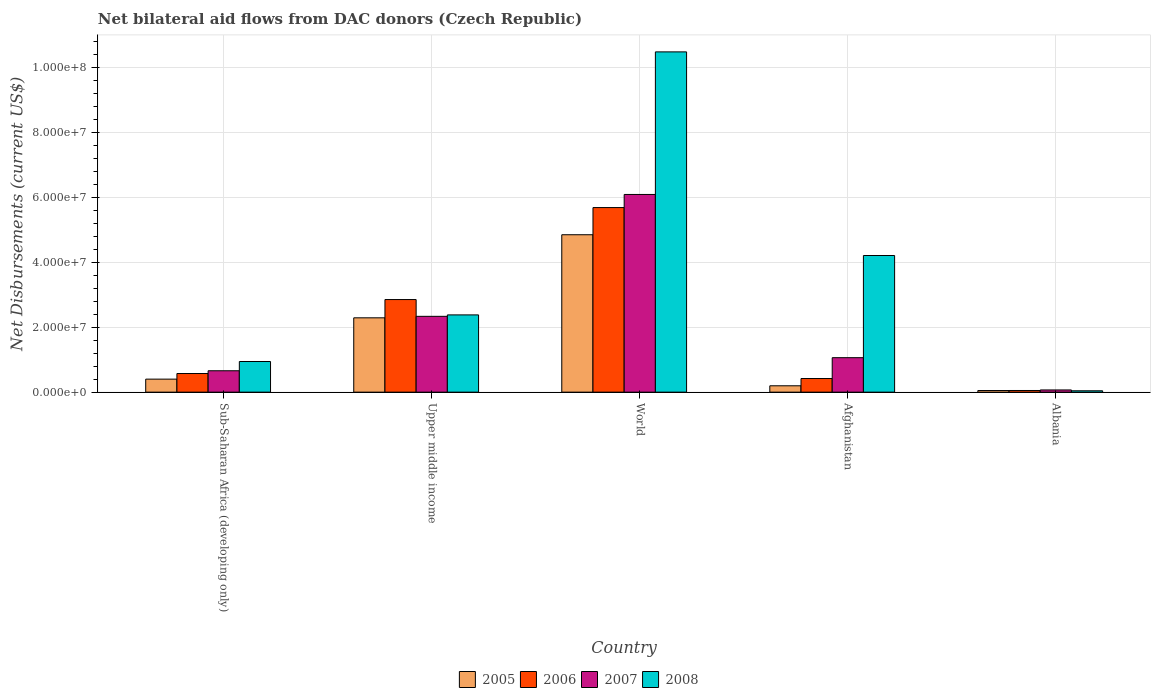How many groups of bars are there?
Your answer should be compact. 5. Are the number of bars per tick equal to the number of legend labels?
Keep it short and to the point. Yes. How many bars are there on the 5th tick from the left?
Give a very brief answer. 4. How many bars are there on the 3rd tick from the right?
Make the answer very short. 4. What is the label of the 3rd group of bars from the left?
Your answer should be very brief. World. What is the net bilateral aid flows in 2008 in World?
Offer a very short reply. 1.05e+08. Across all countries, what is the maximum net bilateral aid flows in 2006?
Give a very brief answer. 5.69e+07. In which country was the net bilateral aid flows in 2005 minimum?
Your response must be concise. Albania. What is the total net bilateral aid flows in 2007 in the graph?
Offer a very short reply. 1.02e+08. What is the difference between the net bilateral aid flows in 2006 in Upper middle income and that in World?
Offer a very short reply. -2.83e+07. What is the difference between the net bilateral aid flows in 2005 in Afghanistan and the net bilateral aid flows in 2007 in World?
Offer a terse response. -5.90e+07. What is the average net bilateral aid flows in 2005 per country?
Your answer should be very brief. 1.56e+07. What is the difference between the net bilateral aid flows of/in 2008 and net bilateral aid flows of/in 2007 in Upper middle income?
Provide a succinct answer. 4.40e+05. In how many countries, is the net bilateral aid flows in 2006 greater than 24000000 US$?
Ensure brevity in your answer.  2. What is the ratio of the net bilateral aid flows in 2005 in Sub-Saharan Africa (developing only) to that in Upper middle income?
Offer a very short reply. 0.18. Is the net bilateral aid flows in 2006 in Albania less than that in Upper middle income?
Provide a succinct answer. Yes. Is the difference between the net bilateral aid flows in 2008 in Sub-Saharan Africa (developing only) and Upper middle income greater than the difference between the net bilateral aid flows in 2007 in Sub-Saharan Africa (developing only) and Upper middle income?
Ensure brevity in your answer.  Yes. What is the difference between the highest and the second highest net bilateral aid flows in 2008?
Ensure brevity in your answer.  6.27e+07. What is the difference between the highest and the lowest net bilateral aid flows in 2008?
Provide a succinct answer. 1.04e+08. Is the sum of the net bilateral aid flows in 2007 in Sub-Saharan Africa (developing only) and World greater than the maximum net bilateral aid flows in 2006 across all countries?
Offer a terse response. Yes. What does the 3rd bar from the left in Upper middle income represents?
Provide a short and direct response. 2007. What does the 1st bar from the right in Upper middle income represents?
Offer a terse response. 2008. Is it the case that in every country, the sum of the net bilateral aid flows in 2007 and net bilateral aid flows in 2008 is greater than the net bilateral aid flows in 2005?
Provide a succinct answer. Yes. How many bars are there?
Give a very brief answer. 20. Are all the bars in the graph horizontal?
Your response must be concise. No. Are the values on the major ticks of Y-axis written in scientific E-notation?
Keep it short and to the point. Yes. Does the graph contain any zero values?
Offer a very short reply. No. Does the graph contain grids?
Ensure brevity in your answer.  Yes. How many legend labels are there?
Give a very brief answer. 4. What is the title of the graph?
Ensure brevity in your answer.  Net bilateral aid flows from DAC donors (Czech Republic). What is the label or title of the X-axis?
Offer a very short reply. Country. What is the label or title of the Y-axis?
Your answer should be very brief. Net Disbursements (current US$). What is the Net Disbursements (current US$) in 2005 in Sub-Saharan Africa (developing only)?
Your answer should be very brief. 4.01e+06. What is the Net Disbursements (current US$) in 2006 in Sub-Saharan Africa (developing only)?
Give a very brief answer. 5.74e+06. What is the Net Disbursements (current US$) in 2007 in Sub-Saharan Africa (developing only)?
Offer a terse response. 6.59e+06. What is the Net Disbursements (current US$) in 2008 in Sub-Saharan Africa (developing only)?
Provide a short and direct response. 9.44e+06. What is the Net Disbursements (current US$) in 2005 in Upper middle income?
Offer a very short reply. 2.29e+07. What is the Net Disbursements (current US$) in 2006 in Upper middle income?
Offer a terse response. 2.85e+07. What is the Net Disbursements (current US$) in 2007 in Upper middle income?
Offer a terse response. 2.34e+07. What is the Net Disbursements (current US$) of 2008 in Upper middle income?
Offer a terse response. 2.38e+07. What is the Net Disbursements (current US$) of 2005 in World?
Offer a terse response. 4.85e+07. What is the Net Disbursements (current US$) in 2006 in World?
Your answer should be very brief. 5.69e+07. What is the Net Disbursements (current US$) of 2007 in World?
Make the answer very short. 6.09e+07. What is the Net Disbursements (current US$) in 2008 in World?
Give a very brief answer. 1.05e+08. What is the Net Disbursements (current US$) in 2005 in Afghanistan?
Give a very brief answer. 1.96e+06. What is the Net Disbursements (current US$) of 2006 in Afghanistan?
Your answer should be compact. 4.20e+06. What is the Net Disbursements (current US$) in 2007 in Afghanistan?
Offer a terse response. 1.06e+07. What is the Net Disbursements (current US$) in 2008 in Afghanistan?
Provide a short and direct response. 4.21e+07. What is the Net Disbursements (current US$) in 2005 in Albania?
Your answer should be very brief. 5.00e+05. What is the Net Disbursements (current US$) in 2006 in Albania?
Provide a short and direct response. 5.10e+05. What is the Net Disbursements (current US$) of 2007 in Albania?
Offer a very short reply. 6.80e+05. Across all countries, what is the maximum Net Disbursements (current US$) of 2005?
Your answer should be compact. 4.85e+07. Across all countries, what is the maximum Net Disbursements (current US$) of 2006?
Provide a short and direct response. 5.69e+07. Across all countries, what is the maximum Net Disbursements (current US$) of 2007?
Keep it short and to the point. 6.09e+07. Across all countries, what is the maximum Net Disbursements (current US$) of 2008?
Make the answer very short. 1.05e+08. Across all countries, what is the minimum Net Disbursements (current US$) of 2006?
Provide a short and direct response. 5.10e+05. Across all countries, what is the minimum Net Disbursements (current US$) in 2007?
Keep it short and to the point. 6.80e+05. What is the total Net Disbursements (current US$) of 2005 in the graph?
Your response must be concise. 7.79e+07. What is the total Net Disbursements (current US$) in 2006 in the graph?
Keep it short and to the point. 9.58e+07. What is the total Net Disbursements (current US$) of 2007 in the graph?
Your response must be concise. 1.02e+08. What is the total Net Disbursements (current US$) of 2008 in the graph?
Keep it short and to the point. 1.81e+08. What is the difference between the Net Disbursements (current US$) of 2005 in Sub-Saharan Africa (developing only) and that in Upper middle income?
Offer a terse response. -1.89e+07. What is the difference between the Net Disbursements (current US$) of 2006 in Sub-Saharan Africa (developing only) and that in Upper middle income?
Your answer should be compact. -2.28e+07. What is the difference between the Net Disbursements (current US$) in 2007 in Sub-Saharan Africa (developing only) and that in Upper middle income?
Offer a very short reply. -1.68e+07. What is the difference between the Net Disbursements (current US$) of 2008 in Sub-Saharan Africa (developing only) and that in Upper middle income?
Ensure brevity in your answer.  -1.44e+07. What is the difference between the Net Disbursements (current US$) of 2005 in Sub-Saharan Africa (developing only) and that in World?
Offer a very short reply. -4.45e+07. What is the difference between the Net Disbursements (current US$) of 2006 in Sub-Saharan Africa (developing only) and that in World?
Ensure brevity in your answer.  -5.11e+07. What is the difference between the Net Disbursements (current US$) of 2007 in Sub-Saharan Africa (developing only) and that in World?
Offer a very short reply. -5.43e+07. What is the difference between the Net Disbursements (current US$) in 2008 in Sub-Saharan Africa (developing only) and that in World?
Your response must be concise. -9.54e+07. What is the difference between the Net Disbursements (current US$) of 2005 in Sub-Saharan Africa (developing only) and that in Afghanistan?
Your answer should be compact. 2.05e+06. What is the difference between the Net Disbursements (current US$) in 2006 in Sub-Saharan Africa (developing only) and that in Afghanistan?
Your answer should be very brief. 1.54e+06. What is the difference between the Net Disbursements (current US$) of 2007 in Sub-Saharan Africa (developing only) and that in Afghanistan?
Offer a very short reply. -4.03e+06. What is the difference between the Net Disbursements (current US$) of 2008 in Sub-Saharan Africa (developing only) and that in Afghanistan?
Give a very brief answer. -3.27e+07. What is the difference between the Net Disbursements (current US$) of 2005 in Sub-Saharan Africa (developing only) and that in Albania?
Ensure brevity in your answer.  3.51e+06. What is the difference between the Net Disbursements (current US$) in 2006 in Sub-Saharan Africa (developing only) and that in Albania?
Ensure brevity in your answer.  5.23e+06. What is the difference between the Net Disbursements (current US$) of 2007 in Sub-Saharan Africa (developing only) and that in Albania?
Make the answer very short. 5.91e+06. What is the difference between the Net Disbursements (current US$) of 2008 in Sub-Saharan Africa (developing only) and that in Albania?
Provide a succinct answer. 9.02e+06. What is the difference between the Net Disbursements (current US$) in 2005 in Upper middle income and that in World?
Provide a succinct answer. -2.56e+07. What is the difference between the Net Disbursements (current US$) in 2006 in Upper middle income and that in World?
Make the answer very short. -2.83e+07. What is the difference between the Net Disbursements (current US$) in 2007 in Upper middle income and that in World?
Your answer should be compact. -3.76e+07. What is the difference between the Net Disbursements (current US$) of 2008 in Upper middle income and that in World?
Make the answer very short. -8.10e+07. What is the difference between the Net Disbursements (current US$) of 2005 in Upper middle income and that in Afghanistan?
Provide a short and direct response. 2.09e+07. What is the difference between the Net Disbursements (current US$) in 2006 in Upper middle income and that in Afghanistan?
Provide a succinct answer. 2.43e+07. What is the difference between the Net Disbursements (current US$) of 2007 in Upper middle income and that in Afghanistan?
Offer a very short reply. 1.27e+07. What is the difference between the Net Disbursements (current US$) of 2008 in Upper middle income and that in Afghanistan?
Offer a very short reply. -1.83e+07. What is the difference between the Net Disbursements (current US$) in 2005 in Upper middle income and that in Albania?
Provide a succinct answer. 2.24e+07. What is the difference between the Net Disbursements (current US$) in 2006 in Upper middle income and that in Albania?
Give a very brief answer. 2.80e+07. What is the difference between the Net Disbursements (current US$) in 2007 in Upper middle income and that in Albania?
Your answer should be compact. 2.27e+07. What is the difference between the Net Disbursements (current US$) in 2008 in Upper middle income and that in Albania?
Give a very brief answer. 2.34e+07. What is the difference between the Net Disbursements (current US$) of 2005 in World and that in Afghanistan?
Give a very brief answer. 4.65e+07. What is the difference between the Net Disbursements (current US$) of 2006 in World and that in Afghanistan?
Make the answer very short. 5.27e+07. What is the difference between the Net Disbursements (current US$) of 2007 in World and that in Afghanistan?
Keep it short and to the point. 5.03e+07. What is the difference between the Net Disbursements (current US$) of 2008 in World and that in Afghanistan?
Give a very brief answer. 6.27e+07. What is the difference between the Net Disbursements (current US$) in 2005 in World and that in Albania?
Provide a short and direct response. 4.80e+07. What is the difference between the Net Disbursements (current US$) of 2006 in World and that in Albania?
Ensure brevity in your answer.  5.64e+07. What is the difference between the Net Disbursements (current US$) of 2007 in World and that in Albania?
Provide a succinct answer. 6.02e+07. What is the difference between the Net Disbursements (current US$) in 2008 in World and that in Albania?
Make the answer very short. 1.04e+08. What is the difference between the Net Disbursements (current US$) in 2005 in Afghanistan and that in Albania?
Make the answer very short. 1.46e+06. What is the difference between the Net Disbursements (current US$) of 2006 in Afghanistan and that in Albania?
Provide a short and direct response. 3.69e+06. What is the difference between the Net Disbursements (current US$) of 2007 in Afghanistan and that in Albania?
Your answer should be very brief. 9.94e+06. What is the difference between the Net Disbursements (current US$) of 2008 in Afghanistan and that in Albania?
Provide a short and direct response. 4.17e+07. What is the difference between the Net Disbursements (current US$) of 2005 in Sub-Saharan Africa (developing only) and the Net Disbursements (current US$) of 2006 in Upper middle income?
Your response must be concise. -2.45e+07. What is the difference between the Net Disbursements (current US$) in 2005 in Sub-Saharan Africa (developing only) and the Net Disbursements (current US$) in 2007 in Upper middle income?
Provide a succinct answer. -1.94e+07. What is the difference between the Net Disbursements (current US$) of 2005 in Sub-Saharan Africa (developing only) and the Net Disbursements (current US$) of 2008 in Upper middle income?
Your answer should be compact. -1.98e+07. What is the difference between the Net Disbursements (current US$) in 2006 in Sub-Saharan Africa (developing only) and the Net Disbursements (current US$) in 2007 in Upper middle income?
Your answer should be compact. -1.76e+07. What is the difference between the Net Disbursements (current US$) in 2006 in Sub-Saharan Africa (developing only) and the Net Disbursements (current US$) in 2008 in Upper middle income?
Your answer should be very brief. -1.81e+07. What is the difference between the Net Disbursements (current US$) of 2007 in Sub-Saharan Africa (developing only) and the Net Disbursements (current US$) of 2008 in Upper middle income?
Provide a succinct answer. -1.72e+07. What is the difference between the Net Disbursements (current US$) of 2005 in Sub-Saharan Africa (developing only) and the Net Disbursements (current US$) of 2006 in World?
Make the answer very short. -5.29e+07. What is the difference between the Net Disbursements (current US$) in 2005 in Sub-Saharan Africa (developing only) and the Net Disbursements (current US$) in 2007 in World?
Your answer should be compact. -5.69e+07. What is the difference between the Net Disbursements (current US$) of 2005 in Sub-Saharan Africa (developing only) and the Net Disbursements (current US$) of 2008 in World?
Offer a terse response. -1.01e+08. What is the difference between the Net Disbursements (current US$) in 2006 in Sub-Saharan Africa (developing only) and the Net Disbursements (current US$) in 2007 in World?
Your answer should be very brief. -5.52e+07. What is the difference between the Net Disbursements (current US$) in 2006 in Sub-Saharan Africa (developing only) and the Net Disbursements (current US$) in 2008 in World?
Give a very brief answer. -9.91e+07. What is the difference between the Net Disbursements (current US$) of 2007 in Sub-Saharan Africa (developing only) and the Net Disbursements (current US$) of 2008 in World?
Offer a terse response. -9.82e+07. What is the difference between the Net Disbursements (current US$) in 2005 in Sub-Saharan Africa (developing only) and the Net Disbursements (current US$) in 2006 in Afghanistan?
Offer a terse response. -1.90e+05. What is the difference between the Net Disbursements (current US$) in 2005 in Sub-Saharan Africa (developing only) and the Net Disbursements (current US$) in 2007 in Afghanistan?
Provide a succinct answer. -6.61e+06. What is the difference between the Net Disbursements (current US$) of 2005 in Sub-Saharan Africa (developing only) and the Net Disbursements (current US$) of 2008 in Afghanistan?
Offer a very short reply. -3.81e+07. What is the difference between the Net Disbursements (current US$) of 2006 in Sub-Saharan Africa (developing only) and the Net Disbursements (current US$) of 2007 in Afghanistan?
Your response must be concise. -4.88e+06. What is the difference between the Net Disbursements (current US$) of 2006 in Sub-Saharan Africa (developing only) and the Net Disbursements (current US$) of 2008 in Afghanistan?
Provide a short and direct response. -3.64e+07. What is the difference between the Net Disbursements (current US$) in 2007 in Sub-Saharan Africa (developing only) and the Net Disbursements (current US$) in 2008 in Afghanistan?
Your answer should be compact. -3.55e+07. What is the difference between the Net Disbursements (current US$) of 2005 in Sub-Saharan Africa (developing only) and the Net Disbursements (current US$) of 2006 in Albania?
Your answer should be very brief. 3.50e+06. What is the difference between the Net Disbursements (current US$) of 2005 in Sub-Saharan Africa (developing only) and the Net Disbursements (current US$) of 2007 in Albania?
Your answer should be compact. 3.33e+06. What is the difference between the Net Disbursements (current US$) in 2005 in Sub-Saharan Africa (developing only) and the Net Disbursements (current US$) in 2008 in Albania?
Ensure brevity in your answer.  3.59e+06. What is the difference between the Net Disbursements (current US$) of 2006 in Sub-Saharan Africa (developing only) and the Net Disbursements (current US$) of 2007 in Albania?
Offer a terse response. 5.06e+06. What is the difference between the Net Disbursements (current US$) of 2006 in Sub-Saharan Africa (developing only) and the Net Disbursements (current US$) of 2008 in Albania?
Give a very brief answer. 5.32e+06. What is the difference between the Net Disbursements (current US$) of 2007 in Sub-Saharan Africa (developing only) and the Net Disbursements (current US$) of 2008 in Albania?
Your answer should be very brief. 6.17e+06. What is the difference between the Net Disbursements (current US$) of 2005 in Upper middle income and the Net Disbursements (current US$) of 2006 in World?
Make the answer very short. -3.40e+07. What is the difference between the Net Disbursements (current US$) of 2005 in Upper middle income and the Net Disbursements (current US$) of 2007 in World?
Provide a succinct answer. -3.80e+07. What is the difference between the Net Disbursements (current US$) of 2005 in Upper middle income and the Net Disbursements (current US$) of 2008 in World?
Provide a short and direct response. -8.19e+07. What is the difference between the Net Disbursements (current US$) of 2006 in Upper middle income and the Net Disbursements (current US$) of 2007 in World?
Provide a short and direct response. -3.24e+07. What is the difference between the Net Disbursements (current US$) in 2006 in Upper middle income and the Net Disbursements (current US$) in 2008 in World?
Keep it short and to the point. -7.63e+07. What is the difference between the Net Disbursements (current US$) of 2007 in Upper middle income and the Net Disbursements (current US$) of 2008 in World?
Provide a short and direct response. -8.15e+07. What is the difference between the Net Disbursements (current US$) in 2005 in Upper middle income and the Net Disbursements (current US$) in 2006 in Afghanistan?
Give a very brief answer. 1.87e+07. What is the difference between the Net Disbursements (current US$) in 2005 in Upper middle income and the Net Disbursements (current US$) in 2007 in Afghanistan?
Provide a succinct answer. 1.23e+07. What is the difference between the Net Disbursements (current US$) of 2005 in Upper middle income and the Net Disbursements (current US$) of 2008 in Afghanistan?
Make the answer very short. -1.92e+07. What is the difference between the Net Disbursements (current US$) of 2006 in Upper middle income and the Net Disbursements (current US$) of 2007 in Afghanistan?
Ensure brevity in your answer.  1.79e+07. What is the difference between the Net Disbursements (current US$) in 2006 in Upper middle income and the Net Disbursements (current US$) in 2008 in Afghanistan?
Keep it short and to the point. -1.36e+07. What is the difference between the Net Disbursements (current US$) of 2007 in Upper middle income and the Net Disbursements (current US$) of 2008 in Afghanistan?
Offer a terse response. -1.87e+07. What is the difference between the Net Disbursements (current US$) of 2005 in Upper middle income and the Net Disbursements (current US$) of 2006 in Albania?
Provide a succinct answer. 2.24e+07. What is the difference between the Net Disbursements (current US$) of 2005 in Upper middle income and the Net Disbursements (current US$) of 2007 in Albania?
Your answer should be very brief. 2.22e+07. What is the difference between the Net Disbursements (current US$) of 2005 in Upper middle income and the Net Disbursements (current US$) of 2008 in Albania?
Provide a short and direct response. 2.25e+07. What is the difference between the Net Disbursements (current US$) in 2006 in Upper middle income and the Net Disbursements (current US$) in 2007 in Albania?
Ensure brevity in your answer.  2.78e+07. What is the difference between the Net Disbursements (current US$) of 2006 in Upper middle income and the Net Disbursements (current US$) of 2008 in Albania?
Your answer should be very brief. 2.81e+07. What is the difference between the Net Disbursements (current US$) of 2007 in Upper middle income and the Net Disbursements (current US$) of 2008 in Albania?
Give a very brief answer. 2.29e+07. What is the difference between the Net Disbursements (current US$) in 2005 in World and the Net Disbursements (current US$) in 2006 in Afghanistan?
Give a very brief answer. 4.43e+07. What is the difference between the Net Disbursements (current US$) in 2005 in World and the Net Disbursements (current US$) in 2007 in Afghanistan?
Your answer should be very brief. 3.79e+07. What is the difference between the Net Disbursements (current US$) of 2005 in World and the Net Disbursements (current US$) of 2008 in Afghanistan?
Keep it short and to the point. 6.40e+06. What is the difference between the Net Disbursements (current US$) in 2006 in World and the Net Disbursements (current US$) in 2007 in Afghanistan?
Your response must be concise. 4.62e+07. What is the difference between the Net Disbursements (current US$) of 2006 in World and the Net Disbursements (current US$) of 2008 in Afghanistan?
Your response must be concise. 1.48e+07. What is the difference between the Net Disbursements (current US$) in 2007 in World and the Net Disbursements (current US$) in 2008 in Afghanistan?
Offer a very short reply. 1.88e+07. What is the difference between the Net Disbursements (current US$) of 2005 in World and the Net Disbursements (current US$) of 2006 in Albania?
Offer a very short reply. 4.80e+07. What is the difference between the Net Disbursements (current US$) of 2005 in World and the Net Disbursements (current US$) of 2007 in Albania?
Your answer should be compact. 4.78e+07. What is the difference between the Net Disbursements (current US$) of 2005 in World and the Net Disbursements (current US$) of 2008 in Albania?
Ensure brevity in your answer.  4.81e+07. What is the difference between the Net Disbursements (current US$) of 2006 in World and the Net Disbursements (current US$) of 2007 in Albania?
Provide a succinct answer. 5.62e+07. What is the difference between the Net Disbursements (current US$) of 2006 in World and the Net Disbursements (current US$) of 2008 in Albania?
Make the answer very short. 5.64e+07. What is the difference between the Net Disbursements (current US$) of 2007 in World and the Net Disbursements (current US$) of 2008 in Albania?
Offer a terse response. 6.05e+07. What is the difference between the Net Disbursements (current US$) in 2005 in Afghanistan and the Net Disbursements (current US$) in 2006 in Albania?
Make the answer very short. 1.45e+06. What is the difference between the Net Disbursements (current US$) of 2005 in Afghanistan and the Net Disbursements (current US$) of 2007 in Albania?
Your answer should be compact. 1.28e+06. What is the difference between the Net Disbursements (current US$) in 2005 in Afghanistan and the Net Disbursements (current US$) in 2008 in Albania?
Your answer should be very brief. 1.54e+06. What is the difference between the Net Disbursements (current US$) of 2006 in Afghanistan and the Net Disbursements (current US$) of 2007 in Albania?
Keep it short and to the point. 3.52e+06. What is the difference between the Net Disbursements (current US$) in 2006 in Afghanistan and the Net Disbursements (current US$) in 2008 in Albania?
Your answer should be compact. 3.78e+06. What is the difference between the Net Disbursements (current US$) in 2007 in Afghanistan and the Net Disbursements (current US$) in 2008 in Albania?
Your answer should be very brief. 1.02e+07. What is the average Net Disbursements (current US$) of 2005 per country?
Your response must be concise. 1.56e+07. What is the average Net Disbursements (current US$) in 2006 per country?
Offer a terse response. 1.92e+07. What is the average Net Disbursements (current US$) in 2007 per country?
Your answer should be compact. 2.04e+07. What is the average Net Disbursements (current US$) of 2008 per country?
Offer a terse response. 3.61e+07. What is the difference between the Net Disbursements (current US$) of 2005 and Net Disbursements (current US$) of 2006 in Sub-Saharan Africa (developing only)?
Your answer should be very brief. -1.73e+06. What is the difference between the Net Disbursements (current US$) of 2005 and Net Disbursements (current US$) of 2007 in Sub-Saharan Africa (developing only)?
Give a very brief answer. -2.58e+06. What is the difference between the Net Disbursements (current US$) of 2005 and Net Disbursements (current US$) of 2008 in Sub-Saharan Africa (developing only)?
Provide a short and direct response. -5.43e+06. What is the difference between the Net Disbursements (current US$) in 2006 and Net Disbursements (current US$) in 2007 in Sub-Saharan Africa (developing only)?
Offer a very short reply. -8.50e+05. What is the difference between the Net Disbursements (current US$) of 2006 and Net Disbursements (current US$) of 2008 in Sub-Saharan Africa (developing only)?
Your answer should be compact. -3.70e+06. What is the difference between the Net Disbursements (current US$) in 2007 and Net Disbursements (current US$) in 2008 in Sub-Saharan Africa (developing only)?
Offer a very short reply. -2.85e+06. What is the difference between the Net Disbursements (current US$) of 2005 and Net Disbursements (current US$) of 2006 in Upper middle income?
Provide a short and direct response. -5.63e+06. What is the difference between the Net Disbursements (current US$) of 2005 and Net Disbursements (current US$) of 2007 in Upper middle income?
Provide a short and direct response. -4.60e+05. What is the difference between the Net Disbursements (current US$) in 2005 and Net Disbursements (current US$) in 2008 in Upper middle income?
Your answer should be compact. -9.00e+05. What is the difference between the Net Disbursements (current US$) of 2006 and Net Disbursements (current US$) of 2007 in Upper middle income?
Your answer should be compact. 5.17e+06. What is the difference between the Net Disbursements (current US$) of 2006 and Net Disbursements (current US$) of 2008 in Upper middle income?
Keep it short and to the point. 4.73e+06. What is the difference between the Net Disbursements (current US$) of 2007 and Net Disbursements (current US$) of 2008 in Upper middle income?
Provide a succinct answer. -4.40e+05. What is the difference between the Net Disbursements (current US$) of 2005 and Net Disbursements (current US$) of 2006 in World?
Keep it short and to the point. -8.37e+06. What is the difference between the Net Disbursements (current US$) in 2005 and Net Disbursements (current US$) in 2007 in World?
Your answer should be compact. -1.24e+07. What is the difference between the Net Disbursements (current US$) of 2005 and Net Disbursements (current US$) of 2008 in World?
Your response must be concise. -5.63e+07. What is the difference between the Net Disbursements (current US$) in 2006 and Net Disbursements (current US$) in 2007 in World?
Your answer should be compact. -4.04e+06. What is the difference between the Net Disbursements (current US$) of 2006 and Net Disbursements (current US$) of 2008 in World?
Make the answer very short. -4.80e+07. What is the difference between the Net Disbursements (current US$) in 2007 and Net Disbursements (current US$) in 2008 in World?
Offer a very short reply. -4.39e+07. What is the difference between the Net Disbursements (current US$) in 2005 and Net Disbursements (current US$) in 2006 in Afghanistan?
Give a very brief answer. -2.24e+06. What is the difference between the Net Disbursements (current US$) in 2005 and Net Disbursements (current US$) in 2007 in Afghanistan?
Ensure brevity in your answer.  -8.66e+06. What is the difference between the Net Disbursements (current US$) in 2005 and Net Disbursements (current US$) in 2008 in Afghanistan?
Offer a terse response. -4.01e+07. What is the difference between the Net Disbursements (current US$) in 2006 and Net Disbursements (current US$) in 2007 in Afghanistan?
Your answer should be very brief. -6.42e+06. What is the difference between the Net Disbursements (current US$) in 2006 and Net Disbursements (current US$) in 2008 in Afghanistan?
Your answer should be compact. -3.79e+07. What is the difference between the Net Disbursements (current US$) in 2007 and Net Disbursements (current US$) in 2008 in Afghanistan?
Your answer should be very brief. -3.15e+07. What is the difference between the Net Disbursements (current US$) of 2005 and Net Disbursements (current US$) of 2006 in Albania?
Provide a short and direct response. -10000. What is the difference between the Net Disbursements (current US$) of 2006 and Net Disbursements (current US$) of 2007 in Albania?
Ensure brevity in your answer.  -1.70e+05. What is the difference between the Net Disbursements (current US$) in 2006 and Net Disbursements (current US$) in 2008 in Albania?
Ensure brevity in your answer.  9.00e+04. What is the difference between the Net Disbursements (current US$) in 2007 and Net Disbursements (current US$) in 2008 in Albania?
Provide a succinct answer. 2.60e+05. What is the ratio of the Net Disbursements (current US$) in 2005 in Sub-Saharan Africa (developing only) to that in Upper middle income?
Your answer should be compact. 0.18. What is the ratio of the Net Disbursements (current US$) in 2006 in Sub-Saharan Africa (developing only) to that in Upper middle income?
Offer a terse response. 0.2. What is the ratio of the Net Disbursements (current US$) in 2007 in Sub-Saharan Africa (developing only) to that in Upper middle income?
Give a very brief answer. 0.28. What is the ratio of the Net Disbursements (current US$) of 2008 in Sub-Saharan Africa (developing only) to that in Upper middle income?
Keep it short and to the point. 0.4. What is the ratio of the Net Disbursements (current US$) of 2005 in Sub-Saharan Africa (developing only) to that in World?
Ensure brevity in your answer.  0.08. What is the ratio of the Net Disbursements (current US$) of 2006 in Sub-Saharan Africa (developing only) to that in World?
Offer a terse response. 0.1. What is the ratio of the Net Disbursements (current US$) of 2007 in Sub-Saharan Africa (developing only) to that in World?
Your response must be concise. 0.11. What is the ratio of the Net Disbursements (current US$) in 2008 in Sub-Saharan Africa (developing only) to that in World?
Provide a short and direct response. 0.09. What is the ratio of the Net Disbursements (current US$) of 2005 in Sub-Saharan Africa (developing only) to that in Afghanistan?
Your answer should be compact. 2.05. What is the ratio of the Net Disbursements (current US$) of 2006 in Sub-Saharan Africa (developing only) to that in Afghanistan?
Provide a succinct answer. 1.37. What is the ratio of the Net Disbursements (current US$) of 2007 in Sub-Saharan Africa (developing only) to that in Afghanistan?
Your answer should be compact. 0.62. What is the ratio of the Net Disbursements (current US$) in 2008 in Sub-Saharan Africa (developing only) to that in Afghanistan?
Your answer should be compact. 0.22. What is the ratio of the Net Disbursements (current US$) in 2005 in Sub-Saharan Africa (developing only) to that in Albania?
Your answer should be very brief. 8.02. What is the ratio of the Net Disbursements (current US$) of 2006 in Sub-Saharan Africa (developing only) to that in Albania?
Offer a terse response. 11.25. What is the ratio of the Net Disbursements (current US$) in 2007 in Sub-Saharan Africa (developing only) to that in Albania?
Provide a short and direct response. 9.69. What is the ratio of the Net Disbursements (current US$) of 2008 in Sub-Saharan Africa (developing only) to that in Albania?
Offer a very short reply. 22.48. What is the ratio of the Net Disbursements (current US$) in 2005 in Upper middle income to that in World?
Your answer should be very brief. 0.47. What is the ratio of the Net Disbursements (current US$) in 2006 in Upper middle income to that in World?
Offer a terse response. 0.5. What is the ratio of the Net Disbursements (current US$) of 2007 in Upper middle income to that in World?
Your answer should be very brief. 0.38. What is the ratio of the Net Disbursements (current US$) of 2008 in Upper middle income to that in World?
Your answer should be compact. 0.23. What is the ratio of the Net Disbursements (current US$) of 2005 in Upper middle income to that in Afghanistan?
Your answer should be very brief. 11.68. What is the ratio of the Net Disbursements (current US$) in 2006 in Upper middle income to that in Afghanistan?
Offer a very short reply. 6.79. What is the ratio of the Net Disbursements (current US$) in 2007 in Upper middle income to that in Afghanistan?
Your answer should be very brief. 2.2. What is the ratio of the Net Disbursements (current US$) of 2008 in Upper middle income to that in Afghanistan?
Ensure brevity in your answer.  0.57. What is the ratio of the Net Disbursements (current US$) in 2005 in Upper middle income to that in Albania?
Provide a succinct answer. 45.8. What is the ratio of the Net Disbursements (current US$) of 2006 in Upper middle income to that in Albania?
Keep it short and to the point. 55.94. What is the ratio of the Net Disbursements (current US$) in 2007 in Upper middle income to that in Albania?
Your response must be concise. 34.35. What is the ratio of the Net Disbursements (current US$) of 2008 in Upper middle income to that in Albania?
Make the answer very short. 56.67. What is the ratio of the Net Disbursements (current US$) of 2005 in World to that in Afghanistan?
Offer a very short reply. 24.74. What is the ratio of the Net Disbursements (current US$) in 2006 in World to that in Afghanistan?
Provide a short and direct response. 13.54. What is the ratio of the Net Disbursements (current US$) of 2007 in World to that in Afghanistan?
Offer a very short reply. 5.74. What is the ratio of the Net Disbursements (current US$) in 2008 in World to that in Afghanistan?
Make the answer very short. 2.49. What is the ratio of the Net Disbursements (current US$) of 2005 in World to that in Albania?
Offer a very short reply. 97. What is the ratio of the Net Disbursements (current US$) in 2006 in World to that in Albania?
Offer a very short reply. 111.51. What is the ratio of the Net Disbursements (current US$) of 2007 in World to that in Albania?
Offer a very short reply. 89.57. What is the ratio of the Net Disbursements (current US$) in 2008 in World to that in Albania?
Give a very brief answer. 249.62. What is the ratio of the Net Disbursements (current US$) of 2005 in Afghanistan to that in Albania?
Offer a terse response. 3.92. What is the ratio of the Net Disbursements (current US$) of 2006 in Afghanistan to that in Albania?
Your response must be concise. 8.24. What is the ratio of the Net Disbursements (current US$) in 2007 in Afghanistan to that in Albania?
Keep it short and to the point. 15.62. What is the ratio of the Net Disbursements (current US$) in 2008 in Afghanistan to that in Albania?
Provide a short and direct response. 100.24. What is the difference between the highest and the second highest Net Disbursements (current US$) in 2005?
Ensure brevity in your answer.  2.56e+07. What is the difference between the highest and the second highest Net Disbursements (current US$) of 2006?
Offer a very short reply. 2.83e+07. What is the difference between the highest and the second highest Net Disbursements (current US$) in 2007?
Ensure brevity in your answer.  3.76e+07. What is the difference between the highest and the second highest Net Disbursements (current US$) of 2008?
Offer a terse response. 6.27e+07. What is the difference between the highest and the lowest Net Disbursements (current US$) of 2005?
Give a very brief answer. 4.80e+07. What is the difference between the highest and the lowest Net Disbursements (current US$) of 2006?
Your answer should be very brief. 5.64e+07. What is the difference between the highest and the lowest Net Disbursements (current US$) of 2007?
Give a very brief answer. 6.02e+07. What is the difference between the highest and the lowest Net Disbursements (current US$) of 2008?
Keep it short and to the point. 1.04e+08. 